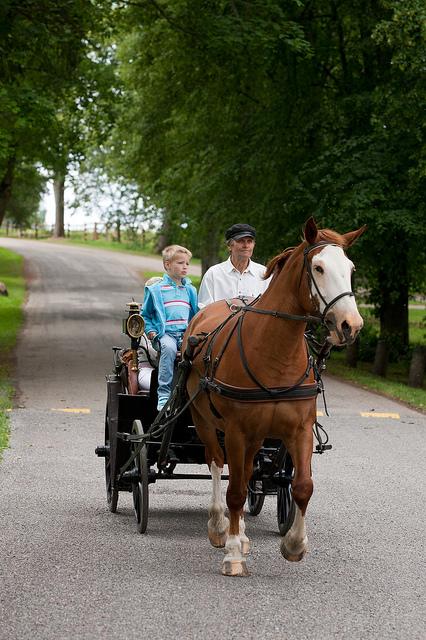How many people are in the carriage?
Keep it brief. 2. What makes this horse look funny?
Quick response, please. White face. Is the road paved?
Answer briefly. Yes. Is the man the father to the son?
Concise answer only. Yes. How many children are in the wagon?
Answer briefly. 1. Why are there yellow broken lines in the road?
Concise answer only. Crosswalk. How many people can you see?
Short answer required. 2. Is the child wearing a hat?
Give a very brief answer. No. How many people are there?
Give a very brief answer. 2. 